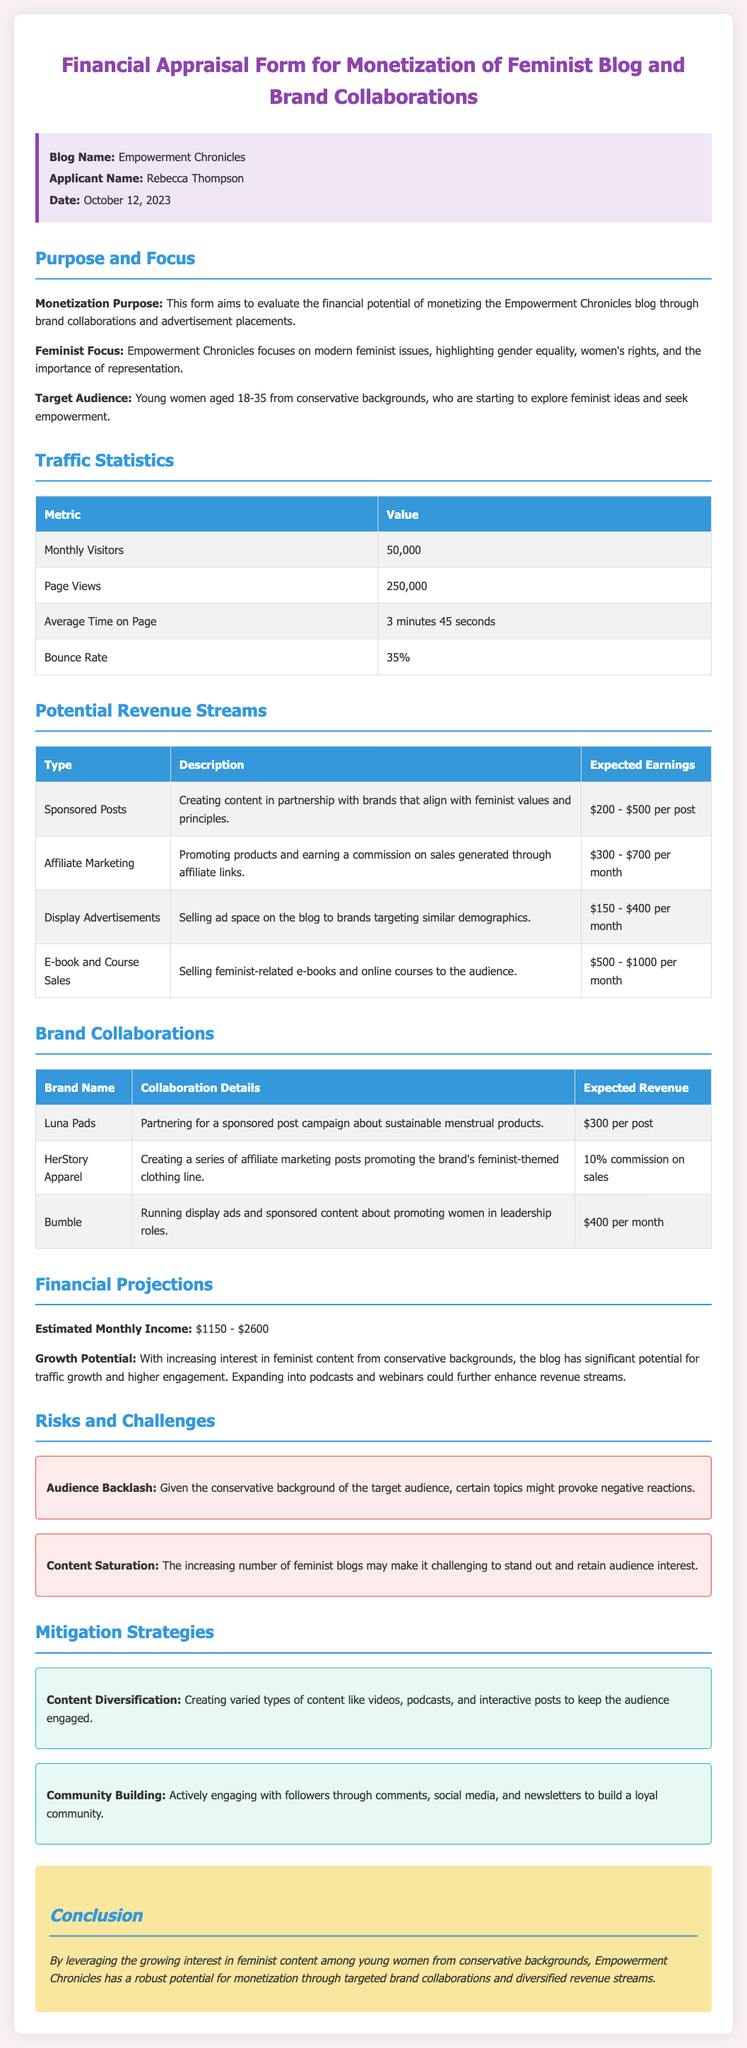What is the blog name? The blog name is provided in the document's title section.
Answer: Empowerment Chronicles Who is the applicant? The applicant's name is mentioned in the info box at the beginning of the document.
Answer: Rebecca Thompson What is the date of the form? The date is explicitly stated in the info box.
Answer: October 12, 2023 How many monthly visitors does the blog have? The number of monthly visitors is listed under traffic statistics.
Answer: 50,000 What is the expected earnings range for sponsored posts? The expected earnings for sponsored posts are specified in the potential revenue streams table.
Answer: $200 - $500 per post What brand is collaborating to promote sustainable menstrual products? The collaboration details mentioning sustainable menstrual products include the brand name.
Answer: Luna Pads What is the estimated monthly income range? The estimated monthly income is mentioned under financial projections.
Answer: $1150 - $2600 What is one risk mentioned in the risks and challenges section? The document lists specific risks, and we need to identify one from that section.
Answer: Audience Backlash What strategy is suggested for community engagement? Strategies for maintaining audience engagement are detailed in the mitigation strategies section.
Answer: Community Building 